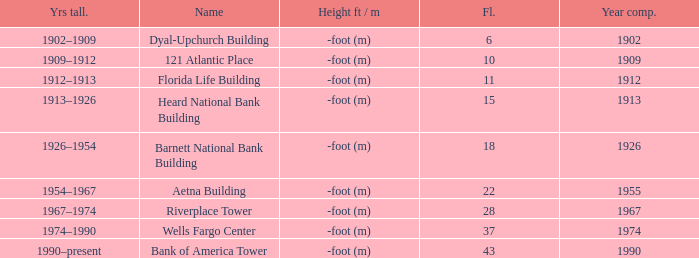What year was the building completed that has 10 floors? 1909.0. 